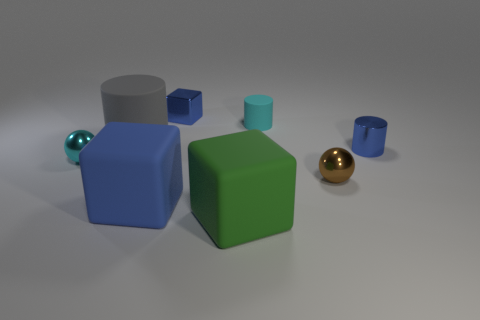Subtract all cyan rubber cylinders. How many cylinders are left? 2 Add 1 tiny blue metal blocks. How many objects exist? 9 Subtract 1 balls. How many balls are left? 1 Subtract all cyan cylinders. How many cylinders are left? 2 Subtract all spheres. How many objects are left? 6 Subtract all gray cylinders. How many blue cubes are left? 2 Add 3 gray objects. How many gray objects are left? 4 Add 1 small purple cylinders. How many small purple cylinders exist? 1 Subtract 1 blue cylinders. How many objects are left? 7 Subtract all gray balls. Subtract all purple blocks. How many balls are left? 2 